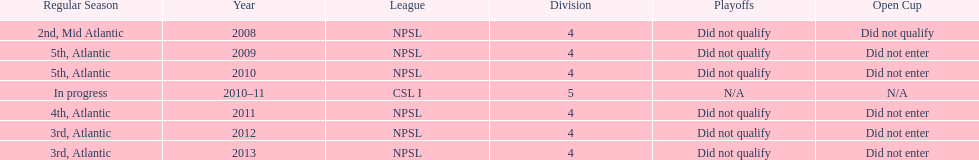Which year was more successful, 2010 or 2013? 2013. 